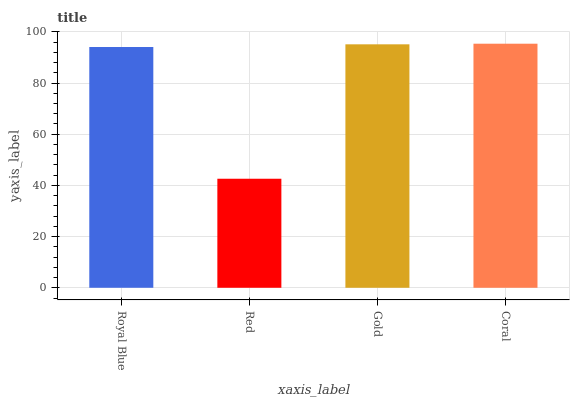Is Red the minimum?
Answer yes or no. Yes. Is Coral the maximum?
Answer yes or no. Yes. Is Gold the minimum?
Answer yes or no. No. Is Gold the maximum?
Answer yes or no. No. Is Gold greater than Red?
Answer yes or no. Yes. Is Red less than Gold?
Answer yes or no. Yes. Is Red greater than Gold?
Answer yes or no. No. Is Gold less than Red?
Answer yes or no. No. Is Gold the high median?
Answer yes or no. Yes. Is Royal Blue the low median?
Answer yes or no. Yes. Is Royal Blue the high median?
Answer yes or no. No. Is Red the low median?
Answer yes or no. No. 